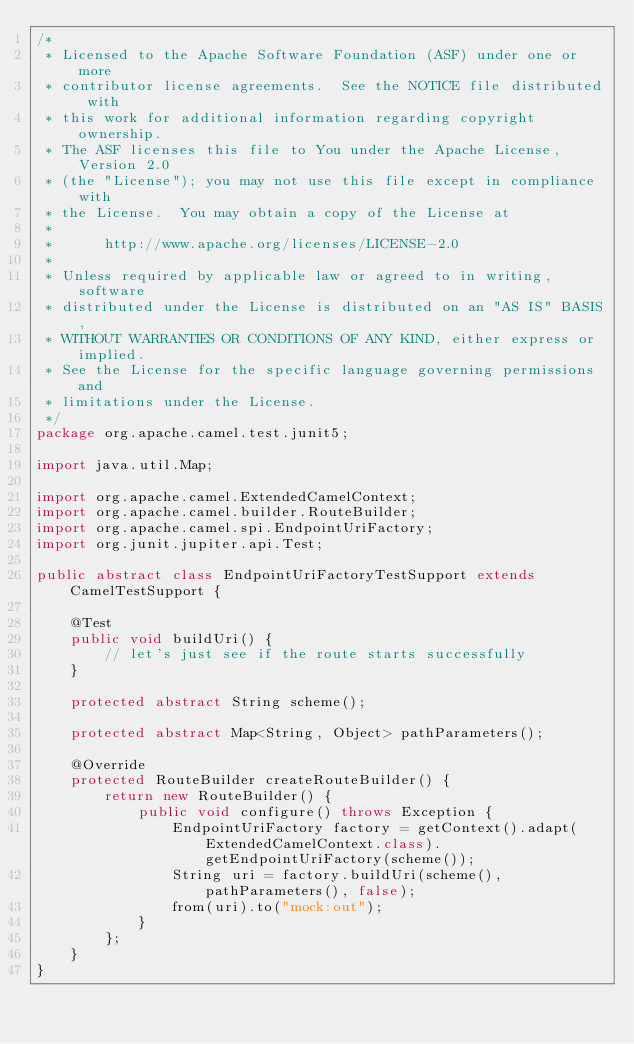<code> <loc_0><loc_0><loc_500><loc_500><_Java_>/*
 * Licensed to the Apache Software Foundation (ASF) under one or more
 * contributor license agreements.  See the NOTICE file distributed with
 * this work for additional information regarding copyright ownership.
 * The ASF licenses this file to You under the Apache License, Version 2.0
 * (the "License"); you may not use this file except in compliance with
 * the License.  You may obtain a copy of the License at
 *
 *      http://www.apache.org/licenses/LICENSE-2.0
 *
 * Unless required by applicable law or agreed to in writing, software
 * distributed under the License is distributed on an "AS IS" BASIS,
 * WITHOUT WARRANTIES OR CONDITIONS OF ANY KIND, either express or implied.
 * See the License for the specific language governing permissions and
 * limitations under the License.
 */
package org.apache.camel.test.junit5;

import java.util.Map;

import org.apache.camel.ExtendedCamelContext;
import org.apache.camel.builder.RouteBuilder;
import org.apache.camel.spi.EndpointUriFactory;
import org.junit.jupiter.api.Test;

public abstract class EndpointUriFactoryTestSupport extends CamelTestSupport {

    @Test
    public void buildUri() {
        // let's just see if the route starts successfully
    }

    protected abstract String scheme();

    protected abstract Map<String, Object> pathParameters();

    @Override
    protected RouteBuilder createRouteBuilder() {
        return new RouteBuilder() {
            public void configure() throws Exception {
                EndpointUriFactory factory = getContext().adapt(ExtendedCamelContext.class).getEndpointUriFactory(scheme());
                String uri = factory.buildUri(scheme(), pathParameters(), false);
                from(uri).to("mock:out");
            }
        };
    }
}
</code> 